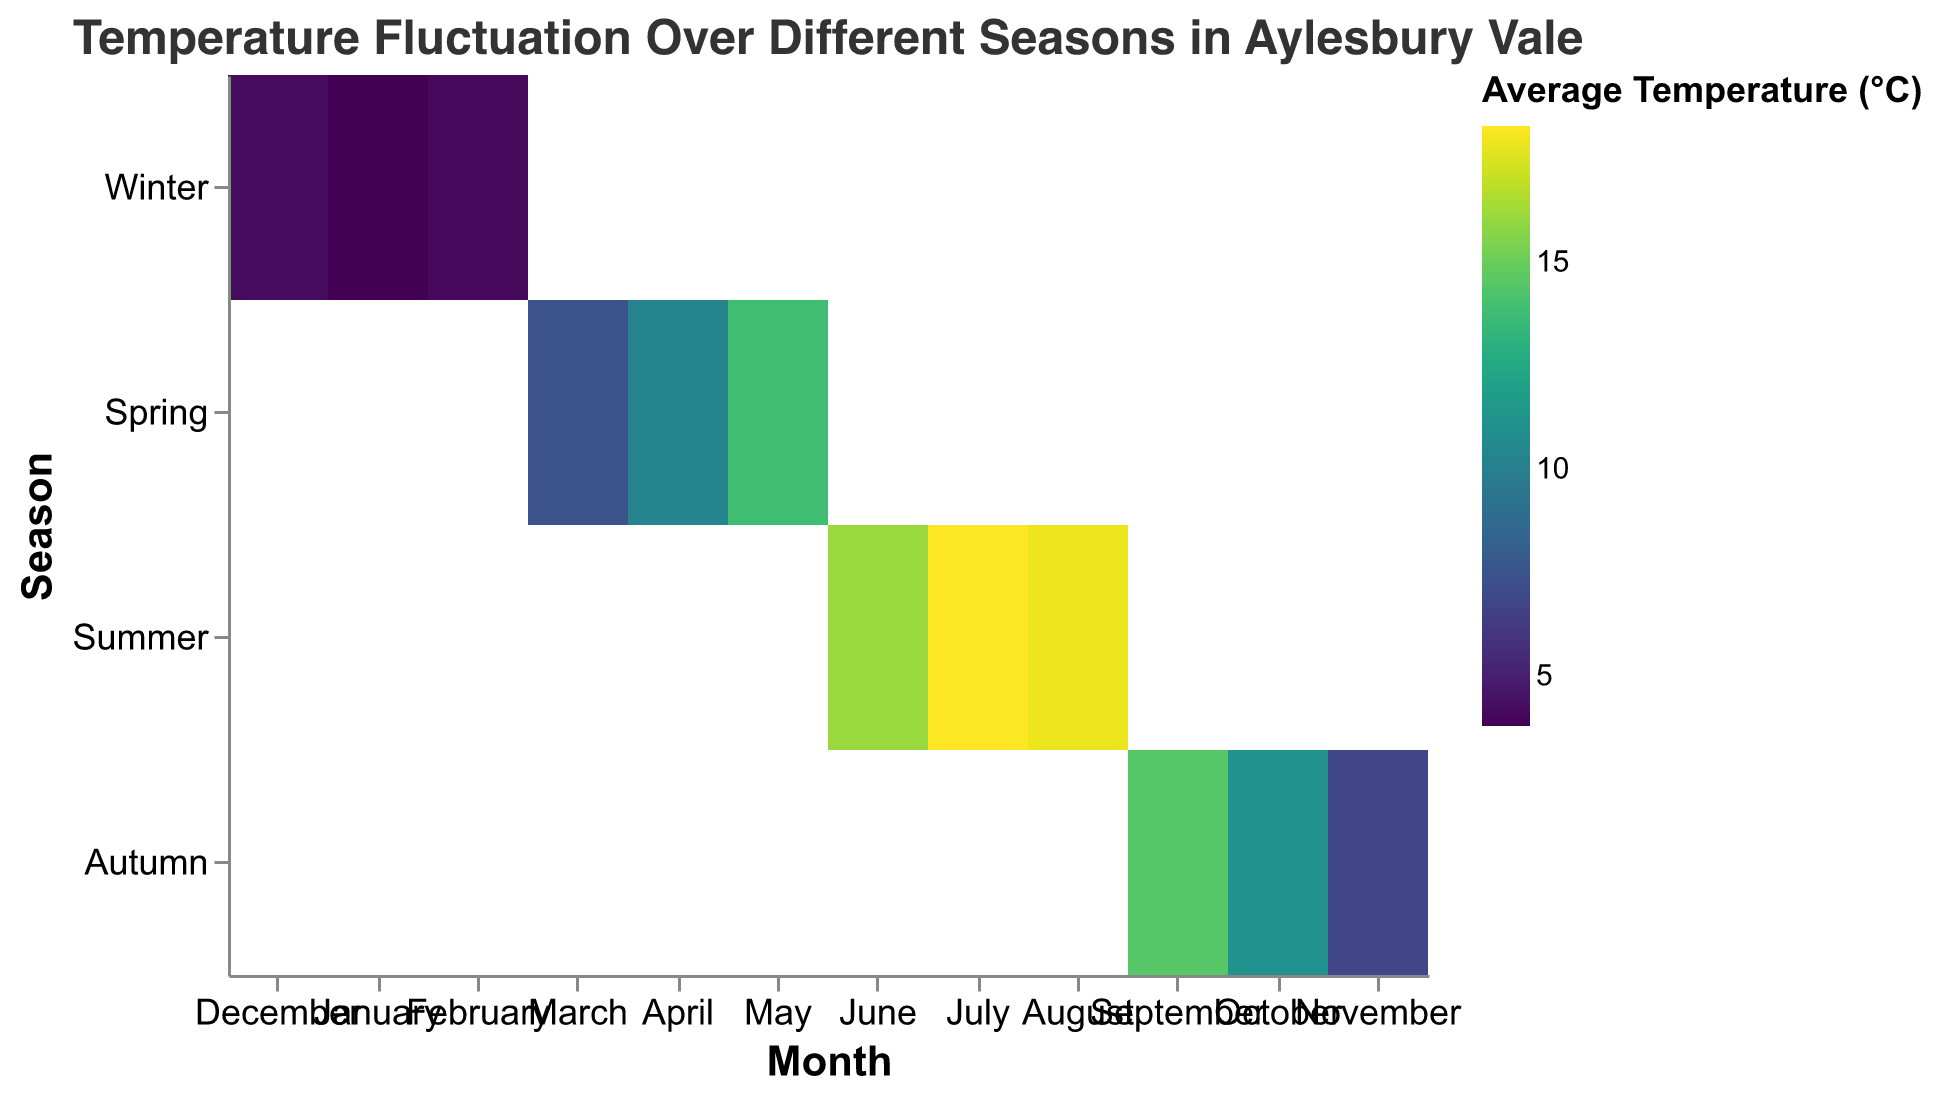What's the title of the figure? The title of the figure is displayed prominently at the top of the heatmap and provides a summary of the subject being visualized. The title reads "Temperature Fluctuation Over Different Seasons in Aylesbury Vale".
Answer: Temperature Fluctuation Over Different Seasons in Aylesbury Vale Which season has the highest average temperature overall? By looking at the heatmap, identify the season with the cells in the highest range of temperatures. Summer has cells with the highest temperature values, ranging up to 18.3°C.
Answer: Summer What is the average temperature in Aylesbury Vale during July? Locate July on the x-axis and note the color intensity for that month under "Summer" on the y-axis. The legend indicates the corresponding temperature is 18.3°C.
Answer: 18.3°C During which month in Winter is the average temperature the lowest? Examine the three Winter months on the x-axis (December, January, February) and compare their color intensities. According to the heatmap, January has the lowest temperature at 3.8°C.
Answer: January Compare the average temperatures in October and April. Which is higher? Identify October in the Autumn row and April in the Spring row, then compare their temperatures. April has an average temperature of 10.3°C, higher than October's 11.1°C.
Answer: April What is the temperature difference between June and November? Find June and November on the heatmap and note their average temperatures: 16.1°C for June and 6.8°C for November. Calculate the difference: 16.1 - 6.8 = 9.3°C.
Answer: 9.3°C During which season does September fall, and what is the average temperature for that month? Look for September along the x-axis and note its position on the y-axis in relation to the season. September falls in Autumn and has an average temperature of 14.5°C.
Answer: Autumn, 14.5°C Which month in Spring experiences the highest average temperature, and what is that temperature? Examine the Spring row and compare the months March, April, and May. May has the highest temperature within Spring months at 13.8°C.
Answer: May, 13.8°C What is the average temperature pattern observed in Summer? Look across the Summer row, noting the temperatures for June, July, and August: 16.1°C, 18.3°C, and 17.9°C respectively. Temperatures start high, peak in July, and slightly decrease in August.
Answer: Increases to a peak in July, then slightly decreases in August How does the temperature trend change from Winter to Spring? Examine the progression of temperatures from December through to May. Winter months (December, January, February) are much colder, ranging from 3.8°C to 4.2°C. Moving into Spring (March, April, May), temperatures gradually increase from 7.4°C in March to 13.8°C in May.
Answer: Increases from 3.8-4.2°C in Winter to 7.4-13.8°C in Spring 